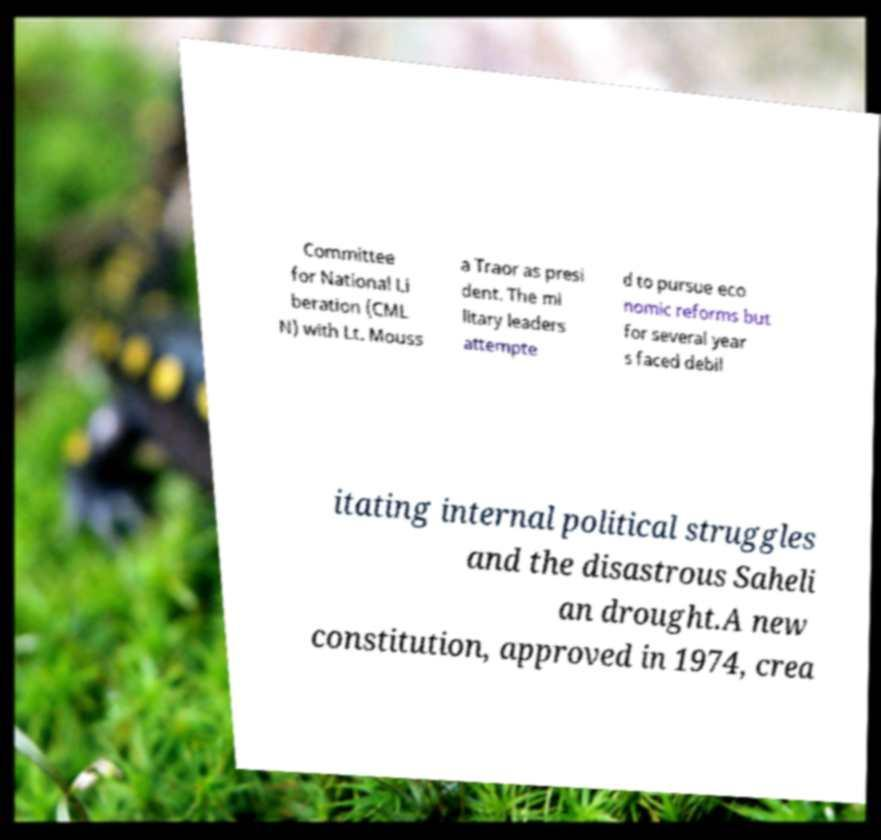For documentation purposes, I need the text within this image transcribed. Could you provide that? Committee for National Li beration (CML N) with Lt. Mouss a Traor as presi dent. The mi litary leaders attempte d to pursue eco nomic reforms but for several year s faced debil itating internal political struggles and the disastrous Saheli an drought.A new constitution, approved in 1974, crea 